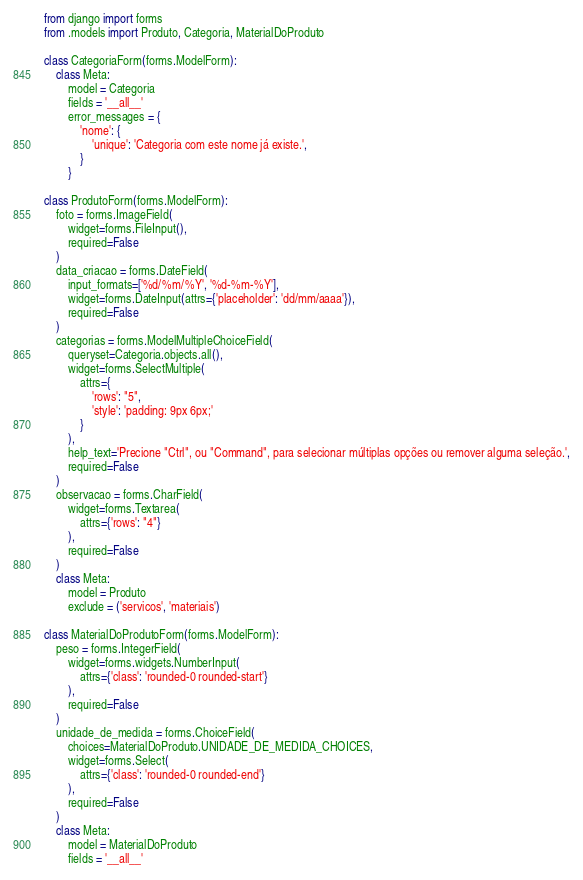<code> <loc_0><loc_0><loc_500><loc_500><_Python_>from django import forms
from .models import Produto, Categoria, MaterialDoProduto

class CategoriaForm(forms.ModelForm):
    class Meta:
        model = Categoria
        fields = '__all__'
        error_messages = {
            'nome': {
                'unique': 'Categoria com este nome já existe.',
            }
        }

class ProdutoForm(forms.ModelForm):
    foto = forms.ImageField(
        widget=forms.FileInput(),
        required=False
    )
    data_criacao = forms.DateField(
        input_formats=['%d/%m/%Y', '%d-%m-%Y'],
        widget=forms.DateInput(attrs={'placeholder': 'dd/mm/aaaa'}),
        required=False
    )
    categorias = forms.ModelMultipleChoiceField(
        queryset=Categoria.objects.all(),
        widget=forms.SelectMultiple(
            attrs={
                'rows': "5",
                'style': 'padding: 9px 6px;'
            }
        ),
        help_text='Precione "Ctrl", ou "Command", para selecionar múltiplas opções ou remover alguma seleção.',
        required=False
    )
    observacao = forms.CharField(
        widget=forms.Textarea(
            attrs={'rows': "4"}
        ),
        required=False
    )
    class Meta:
        model = Produto
        exclude = ('servicos', 'materiais')

class MaterialDoProdutoForm(forms.ModelForm):
    peso = forms.IntegerField(
        widget=forms.widgets.NumberInput(
            attrs={'class': 'rounded-0 rounded-start'}
        ),
        required=False
    )
    unidade_de_medida = forms.ChoiceField(
        choices=MaterialDoProduto.UNIDADE_DE_MEDIDA_CHOICES,
        widget=forms.Select(
            attrs={'class': 'rounded-0 rounded-end'}
        ),
        required=False
    )
    class Meta:
        model = MaterialDoProduto
        fields = '__all__'</code> 